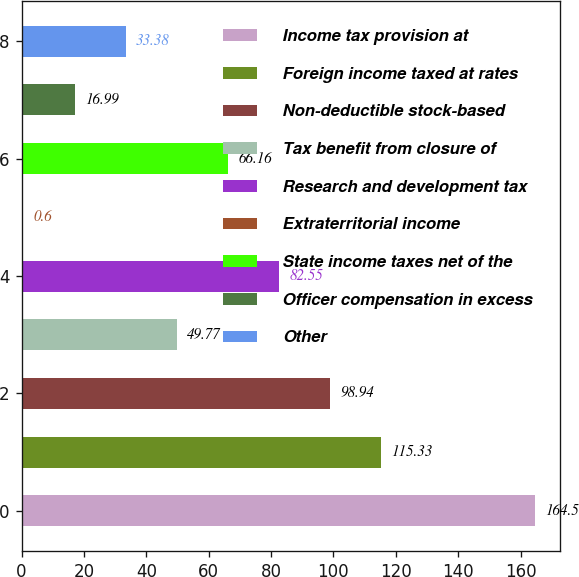<chart> <loc_0><loc_0><loc_500><loc_500><bar_chart><fcel>Income tax provision at<fcel>Foreign income taxed at rates<fcel>Non-deductible stock-based<fcel>Tax benefit from closure of<fcel>Research and development tax<fcel>Extraterritorial income<fcel>State income taxes net of the<fcel>Officer compensation in excess<fcel>Other<nl><fcel>164.5<fcel>115.33<fcel>98.94<fcel>49.77<fcel>82.55<fcel>0.6<fcel>66.16<fcel>16.99<fcel>33.38<nl></chart> 